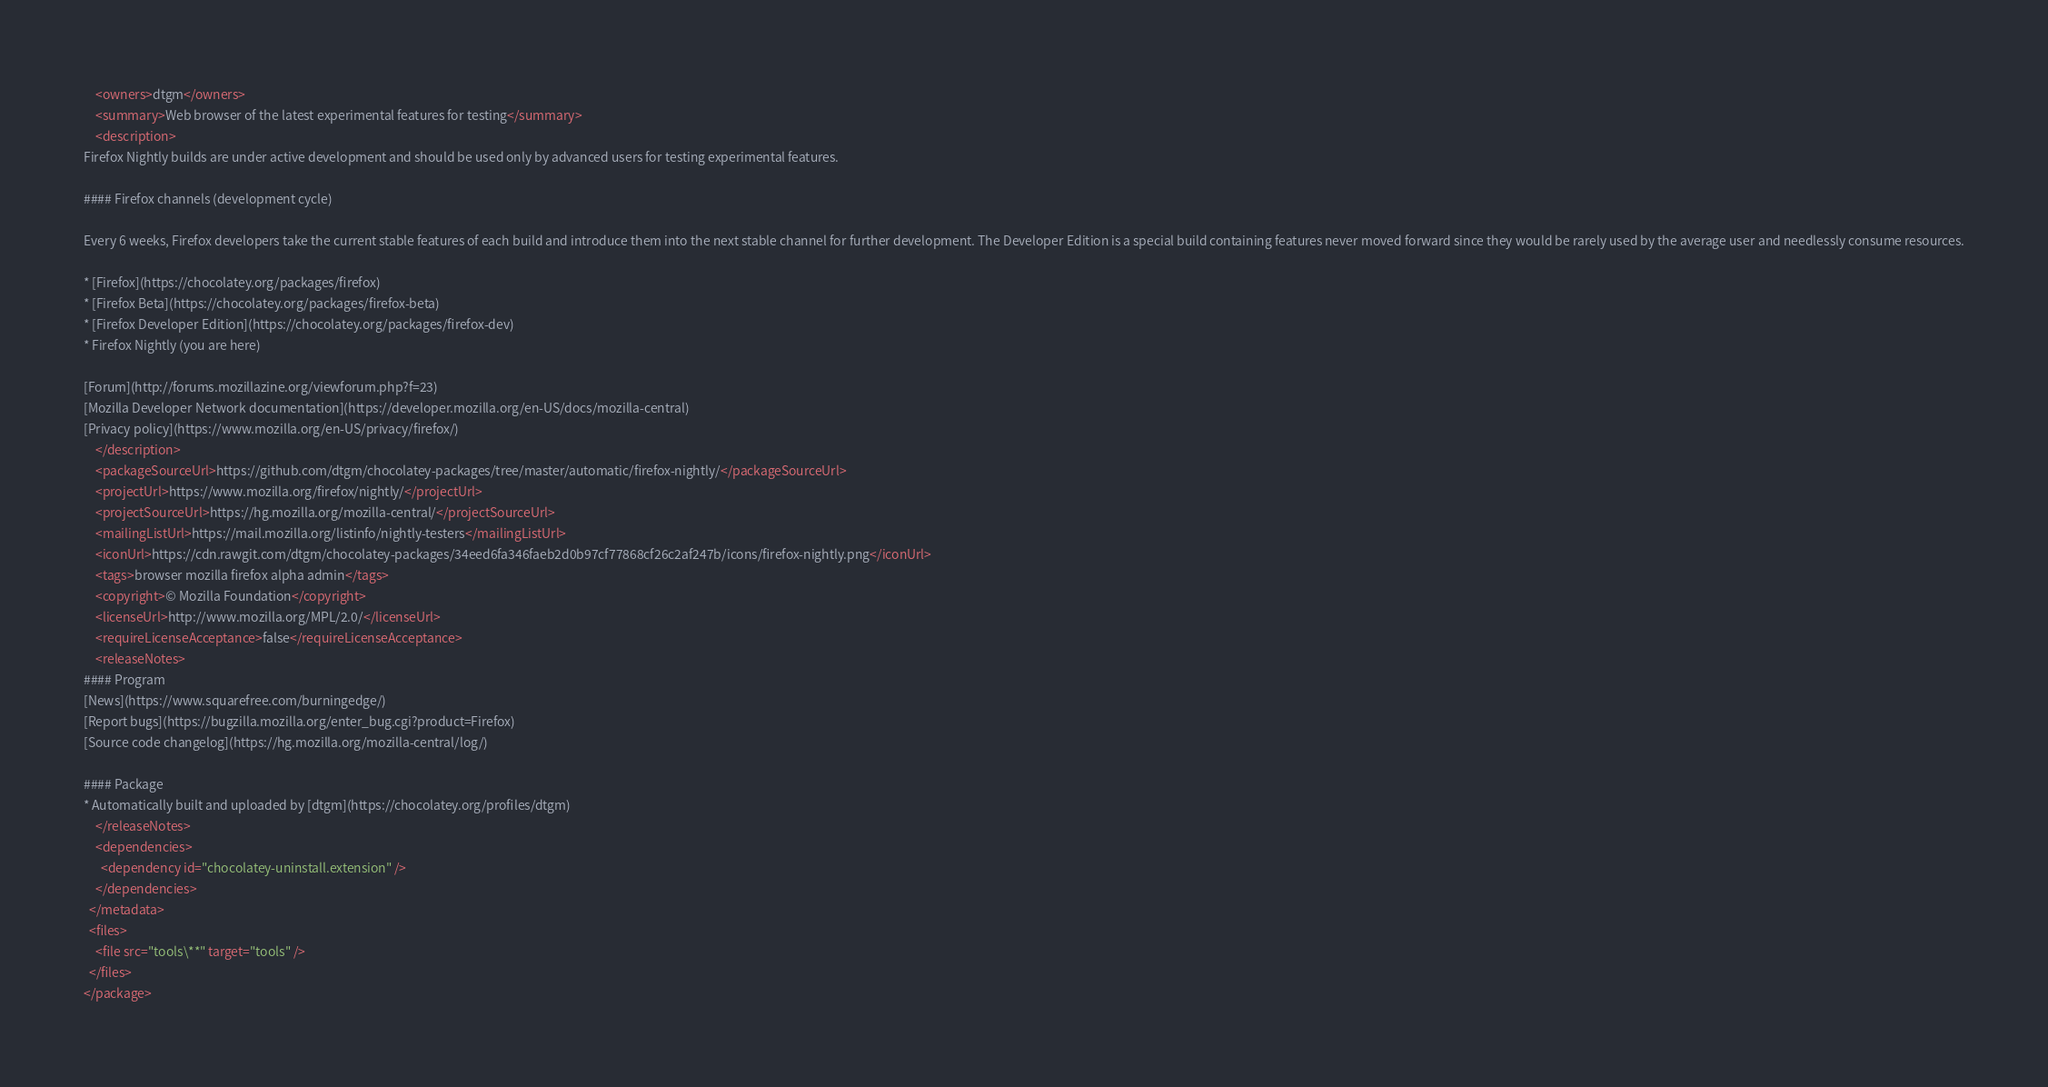<code> <loc_0><loc_0><loc_500><loc_500><_XML_>    <owners>dtgm</owners>
    <summary>Web browser of the latest experimental features for testing</summary>
    <description>
Firefox Nightly builds are under active development and should be used only by advanced users for testing experimental features.

#### Firefox channels (development cycle)

Every 6 weeks, Firefox developers take the current stable features of each build and introduce them into the next stable channel for further development. The Developer Edition is a special build containing features never moved forward since they would be rarely used by the average user and needlessly consume resources.

* [Firefox](https://chocolatey.org/packages/firefox)
* [Firefox Beta](https://chocolatey.org/packages/firefox-beta)
* [Firefox Developer Edition](https://chocolatey.org/packages/firefox-dev)
* Firefox Nightly (you are here)

[Forum](http://forums.mozillazine.org/viewforum.php?f=23)
[Mozilla Developer Network documentation](https://developer.mozilla.org/en-US/docs/mozilla-central)
[Privacy policy](https://www.mozilla.org/en-US/privacy/firefox/)
    </description>
    <packageSourceUrl>https://github.com/dtgm/chocolatey-packages/tree/master/automatic/firefox-nightly/</packageSourceUrl>
    <projectUrl>https://www.mozilla.org/firefox/nightly/</projectUrl>
    <projectSourceUrl>https://hg.mozilla.org/mozilla-central/</projectSourceUrl>
    <mailingListUrl>https://mail.mozilla.org/listinfo/nightly-testers</mailingListUrl>
    <iconUrl>https://cdn.rawgit.com/dtgm/chocolatey-packages/34eed6fa346faeb2d0b97cf77868cf26c2af247b/icons/firefox-nightly.png</iconUrl>
    <tags>browser mozilla firefox alpha admin</tags>
    <copyright>© Mozilla Foundation</copyright>
    <licenseUrl>http://www.mozilla.org/MPL/2.0/</licenseUrl>
    <requireLicenseAcceptance>false</requireLicenseAcceptance>
    <releaseNotes>
#### Program
[News](https://www.squarefree.com/burningedge/)
[Report bugs](https://bugzilla.mozilla.org/enter_bug.cgi?product=Firefox)
[Source code changelog](https://hg.mozilla.org/mozilla-central/log/)

#### Package
* Automatically built and uploaded by [dtgm](https://chocolatey.org/profiles/dtgm)
    </releaseNotes>
    <dependencies>
      <dependency id="chocolatey-uninstall.extension" />
    </dependencies>
  </metadata>
  <files>
    <file src="tools\**" target="tools" />
  </files>
</package></code> 